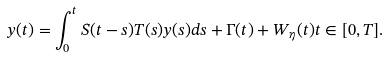<formula> <loc_0><loc_0><loc_500><loc_500>y ( t ) = \int _ { 0 } ^ { t } S ( t - s ) T ( s ) y ( s ) d s + \Gamma ( t ) + W _ { \eta } ( t ) t \in [ 0 , T ] .</formula> 